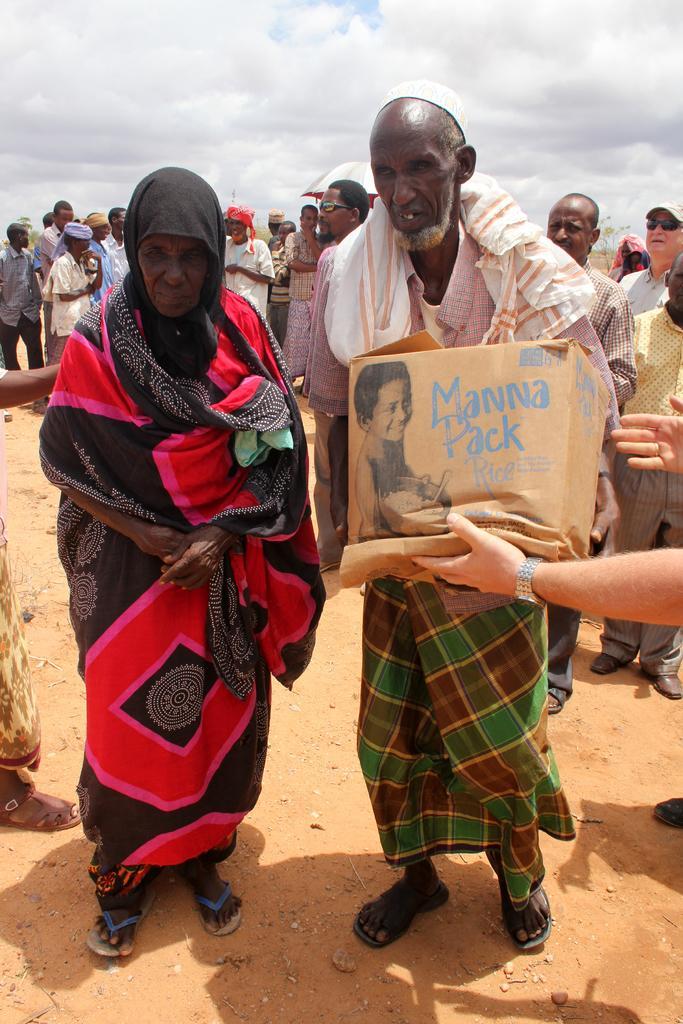Please provide a concise description of this image. In this image, I can see a group of people standing. On the right side of the image, I can see a person's hand holding a cardboard box. In the background, there is the sky. 